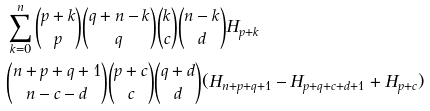<formula> <loc_0><loc_0><loc_500><loc_500>& \sum _ { k = 0 } ^ { n } \binom { p + k } { p } \binom { q + n - k } { q } \binom { k } { c } \binom { n - k } { d } H _ { p + k } \\ & \binom { n + p + q + 1 } { n - c - d } \binom { p + c } { c } \binom { q + d } { d } ( H _ { n + p + q + 1 } - H _ { p + q + c + d + 1 } + H _ { p + c } )</formula> 